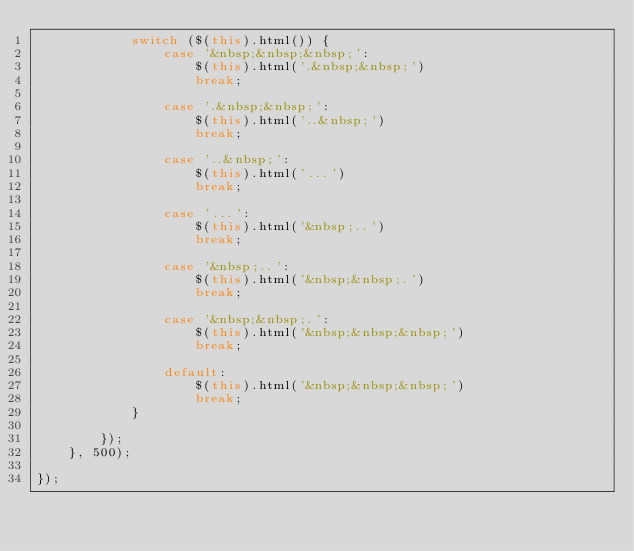<code> <loc_0><loc_0><loc_500><loc_500><_JavaScript_>            switch ($(this).html()) {
                case '&nbsp;&nbsp;&nbsp;':
                    $(this).html('.&nbsp;&nbsp;')
                    break;

                case '.&nbsp;&nbsp;':
                    $(this).html('..&nbsp;')
                    break;

                case '..&nbsp;':
                    $(this).html('...')
                    break;

                case '...':
                    $(this).html('&nbsp;..')
                    break;

                case '&nbsp;..':
                    $(this).html('&nbsp;&nbsp;.')
                    break;

                case '&nbsp;&nbsp;.':
                    $(this).html('&nbsp;&nbsp;&nbsp;')
                    break;

                default:
                    $(this).html('&nbsp;&nbsp;&nbsp;')
                    break;
            }

        });
    }, 500);

});</code> 